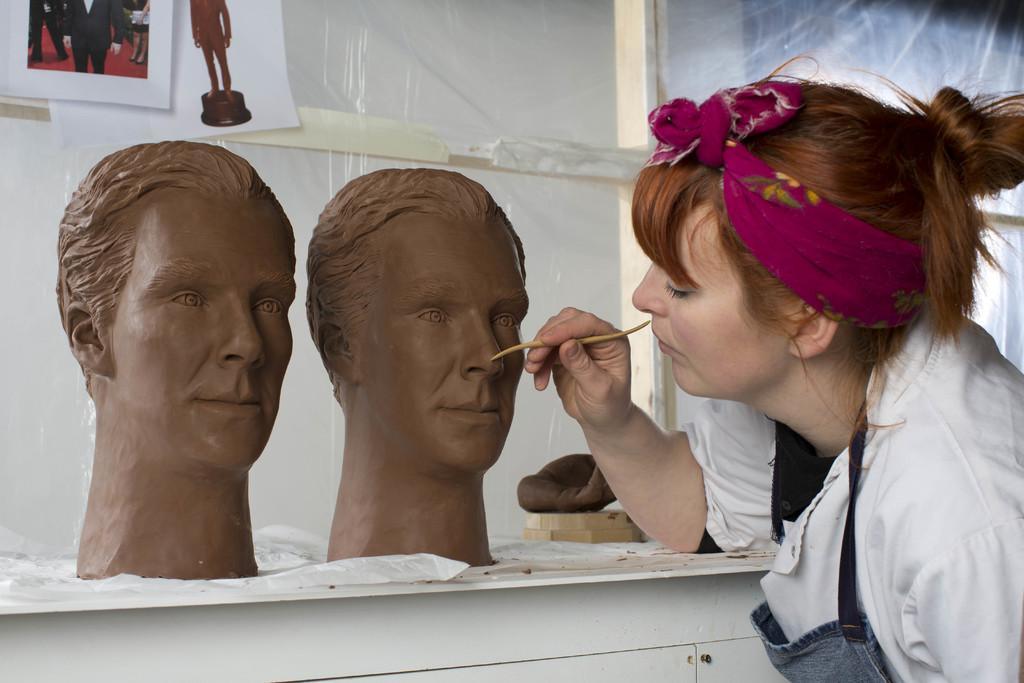Please provide a concise description of this image. In the image there is a woman on the right side in white dress carving statues of two men faces on a table and behind it there are photographs on the wall. 